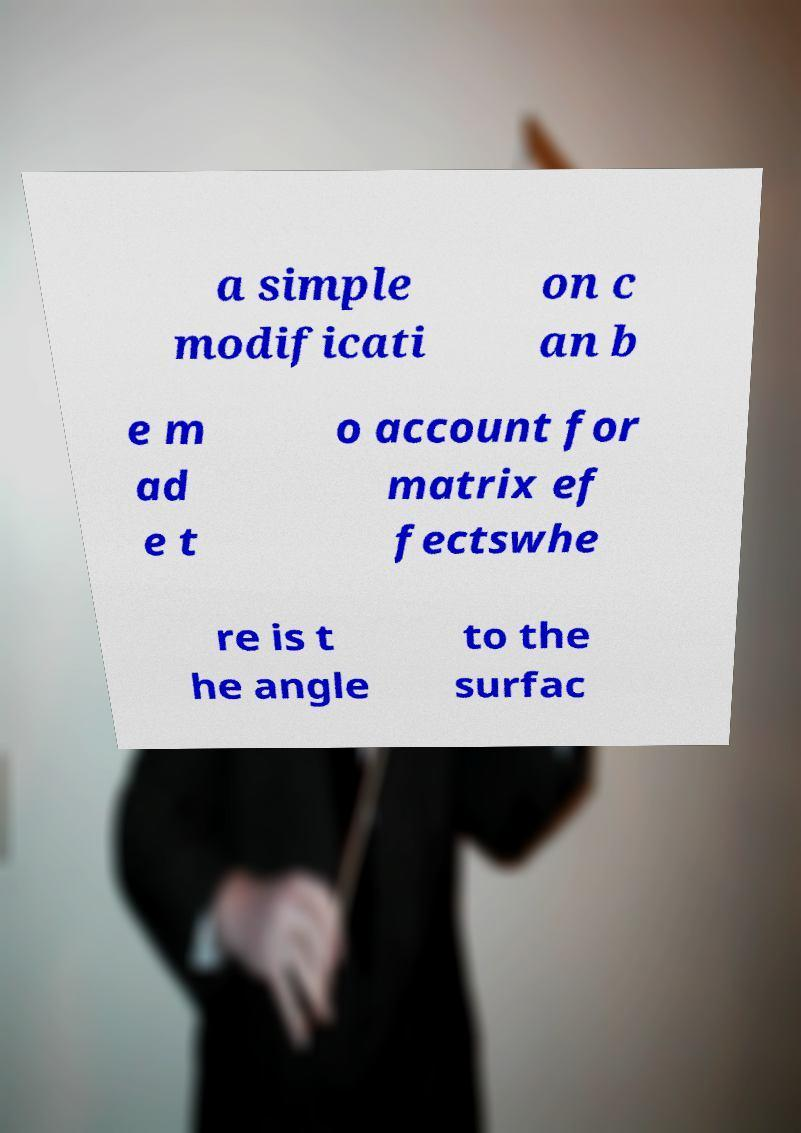I need the written content from this picture converted into text. Can you do that? a simple modificati on c an b e m ad e t o account for matrix ef fectswhe re is t he angle to the surfac 